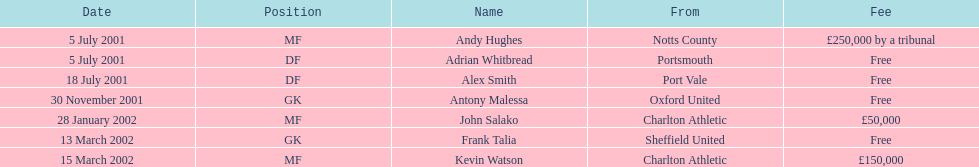Give me the full table as a dictionary. {'header': ['Date', 'Position', 'Name', 'From', 'Fee'], 'rows': [['5 July 2001', 'MF', 'Andy Hughes', 'Notts County', '£250,000 by a tribunal'], ['5 July 2001', 'DF', 'Adrian Whitbread', 'Portsmouth', 'Free'], ['18 July 2001', 'DF', 'Alex Smith', 'Port Vale', 'Free'], ['30 November 2001', 'GK', 'Antony Malessa', 'Oxford United', 'Free'], ['28 January 2002', 'MF', 'John Salako', 'Charlton Athletic', '£50,000'], ['13 March 2002', 'GK', 'Frank Talia', 'Sheffield United', 'Free'], ['15 March 2002', 'MF', 'Kevin Watson', 'Charlton Athletic', '£150,000']]} Did andy hughes or john salako require the biggest fee? Andy Hughes. 